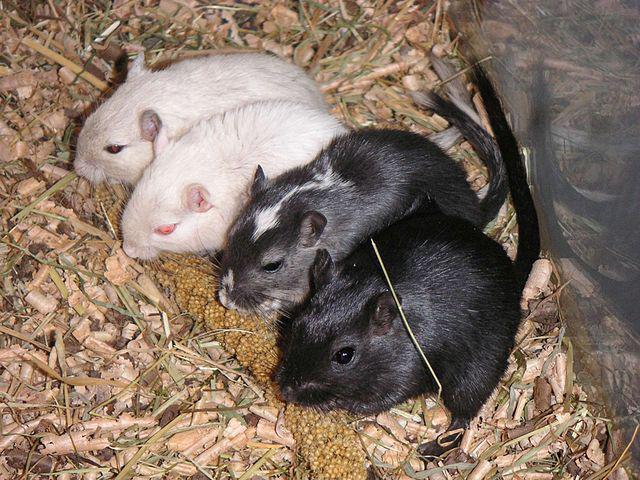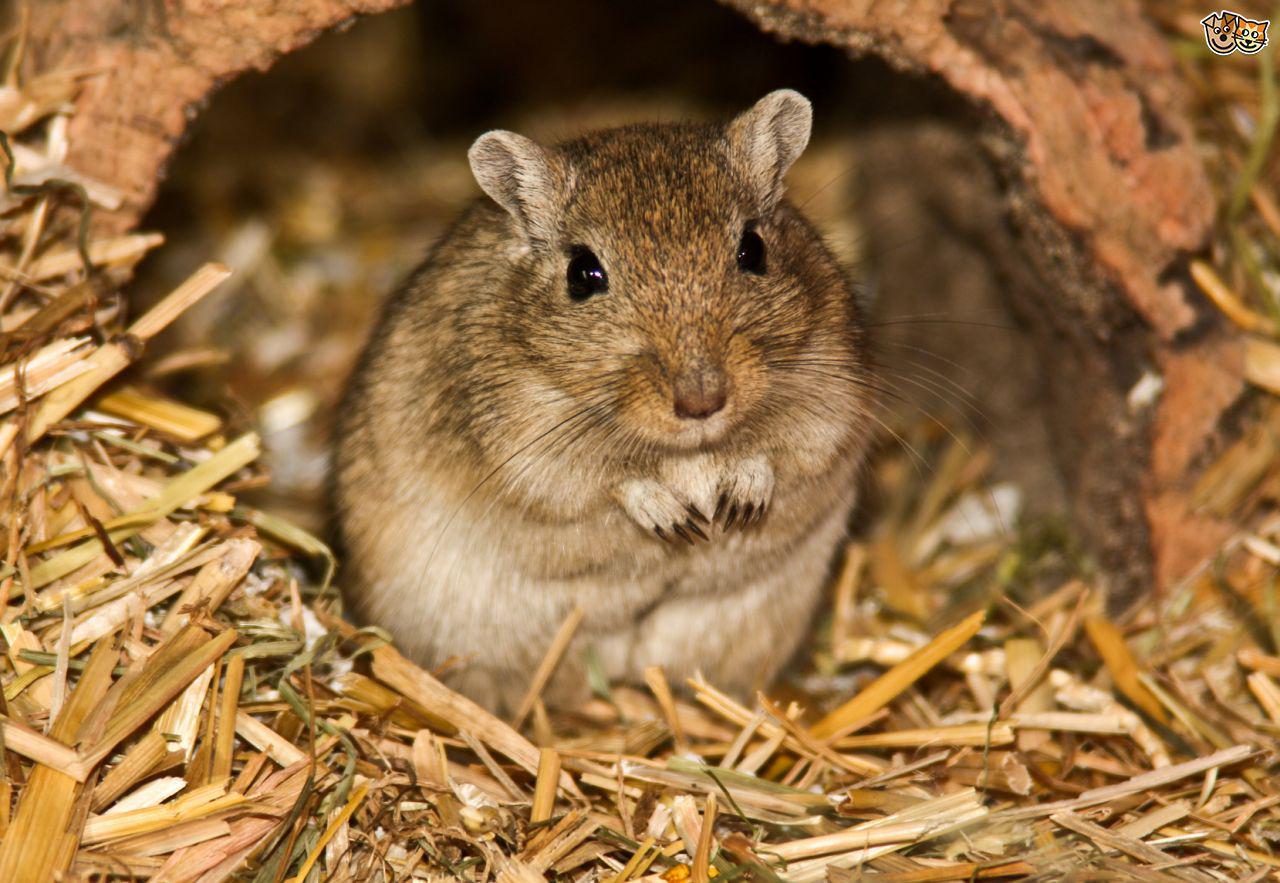The first image is the image on the left, the second image is the image on the right. Considering the images on both sides, is "At least one of the rodents is resting in a human hand." valid? Answer yes or no. No. The first image is the image on the left, the second image is the image on the right. Examine the images to the left and right. Is the description "In one of the images, at least one rodent is being held by a human hand." accurate? Answer yes or no. No. 